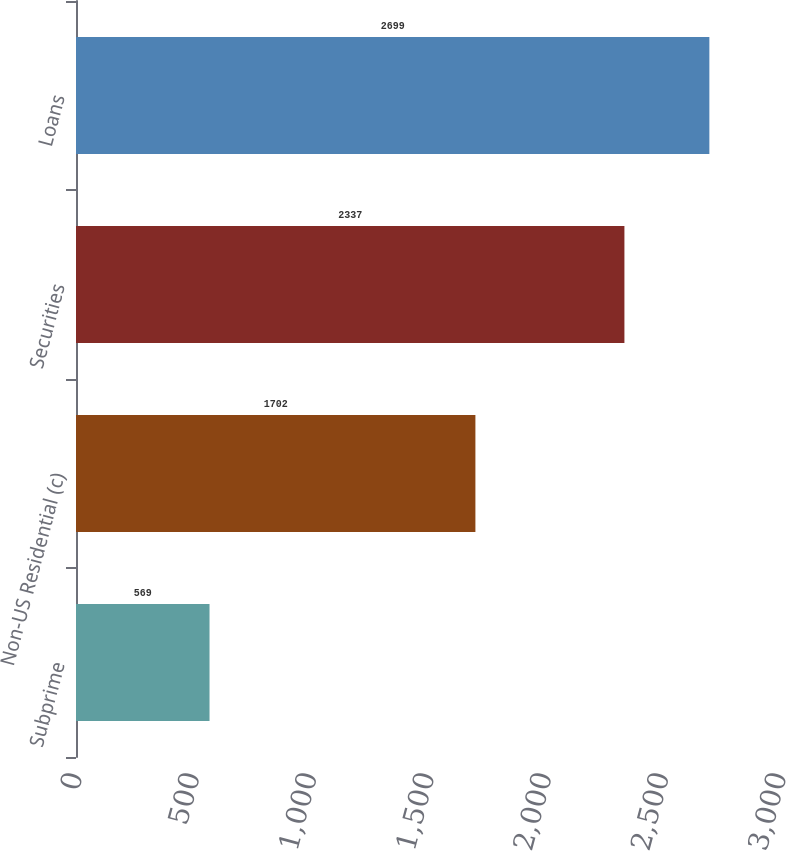<chart> <loc_0><loc_0><loc_500><loc_500><bar_chart><fcel>Subprime<fcel>Non-US Residential (c)<fcel>Securities<fcel>Loans<nl><fcel>569<fcel>1702<fcel>2337<fcel>2699<nl></chart> 